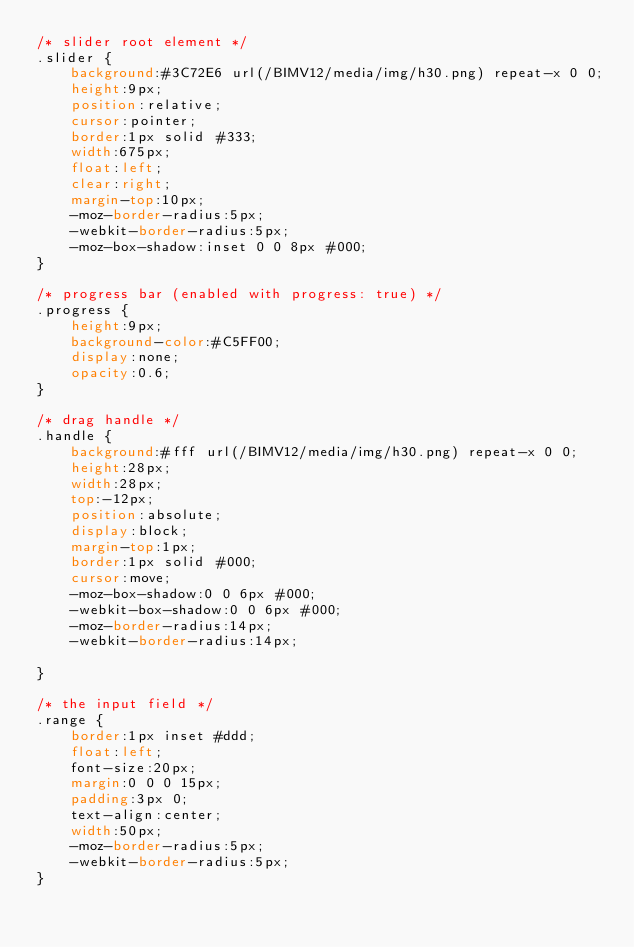<code> <loc_0><loc_0><loc_500><loc_500><_CSS_>/* slider root element */
.slider {
    background:#3C72E6 url(/BIMV12/media/img/h30.png) repeat-x 0 0;
    height:9px;
    position:relative;
    cursor:pointer;
    border:1px solid #333;
    width:675px;
    float:left;
    clear:right;
    margin-top:10px;
    -moz-border-radius:5px;
    -webkit-border-radius:5px;
    -moz-box-shadow:inset 0 0 8px #000;
}

/* progress bar (enabled with progress: true) */
.progress {
    height:9px;
    background-color:#C5FF00;
    display:none;
    opacity:0.6;
}

/* drag handle */
.handle {
    background:#fff url(/BIMV12/media/img/h30.png) repeat-x 0 0;
    height:28px;
    width:28px;
    top:-12px;
    position:absolute;
    display:block;
    margin-top:1px;
    border:1px solid #000;
    cursor:move;
    -moz-box-shadow:0 0 6px #000;
    -webkit-box-shadow:0 0 6px #000;
    -moz-border-radius:14px;
    -webkit-border-radius:14px;

}

/* the input field */
.range {
    border:1px inset #ddd;
    float:left;
    font-size:20px;
    margin:0 0 0 15px;
    padding:3px 0;
    text-align:center;
    width:50px;
    -moz-border-radius:5px;
    -webkit-border-radius:5px;
}
</code> 